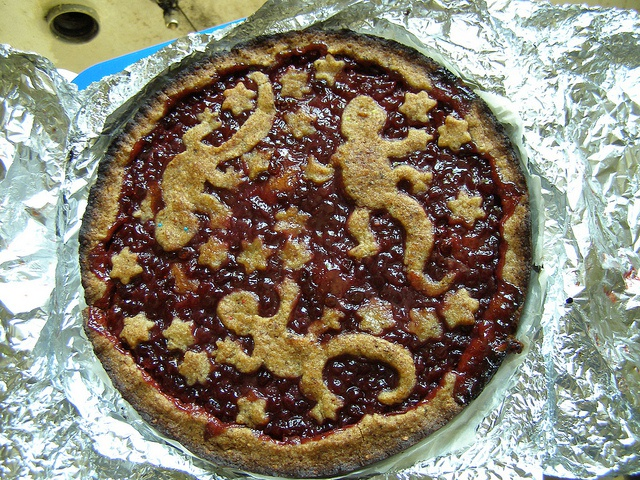Describe the objects in this image and their specific colors. I can see a cake in khaki, black, maroon, tan, and olive tones in this image. 